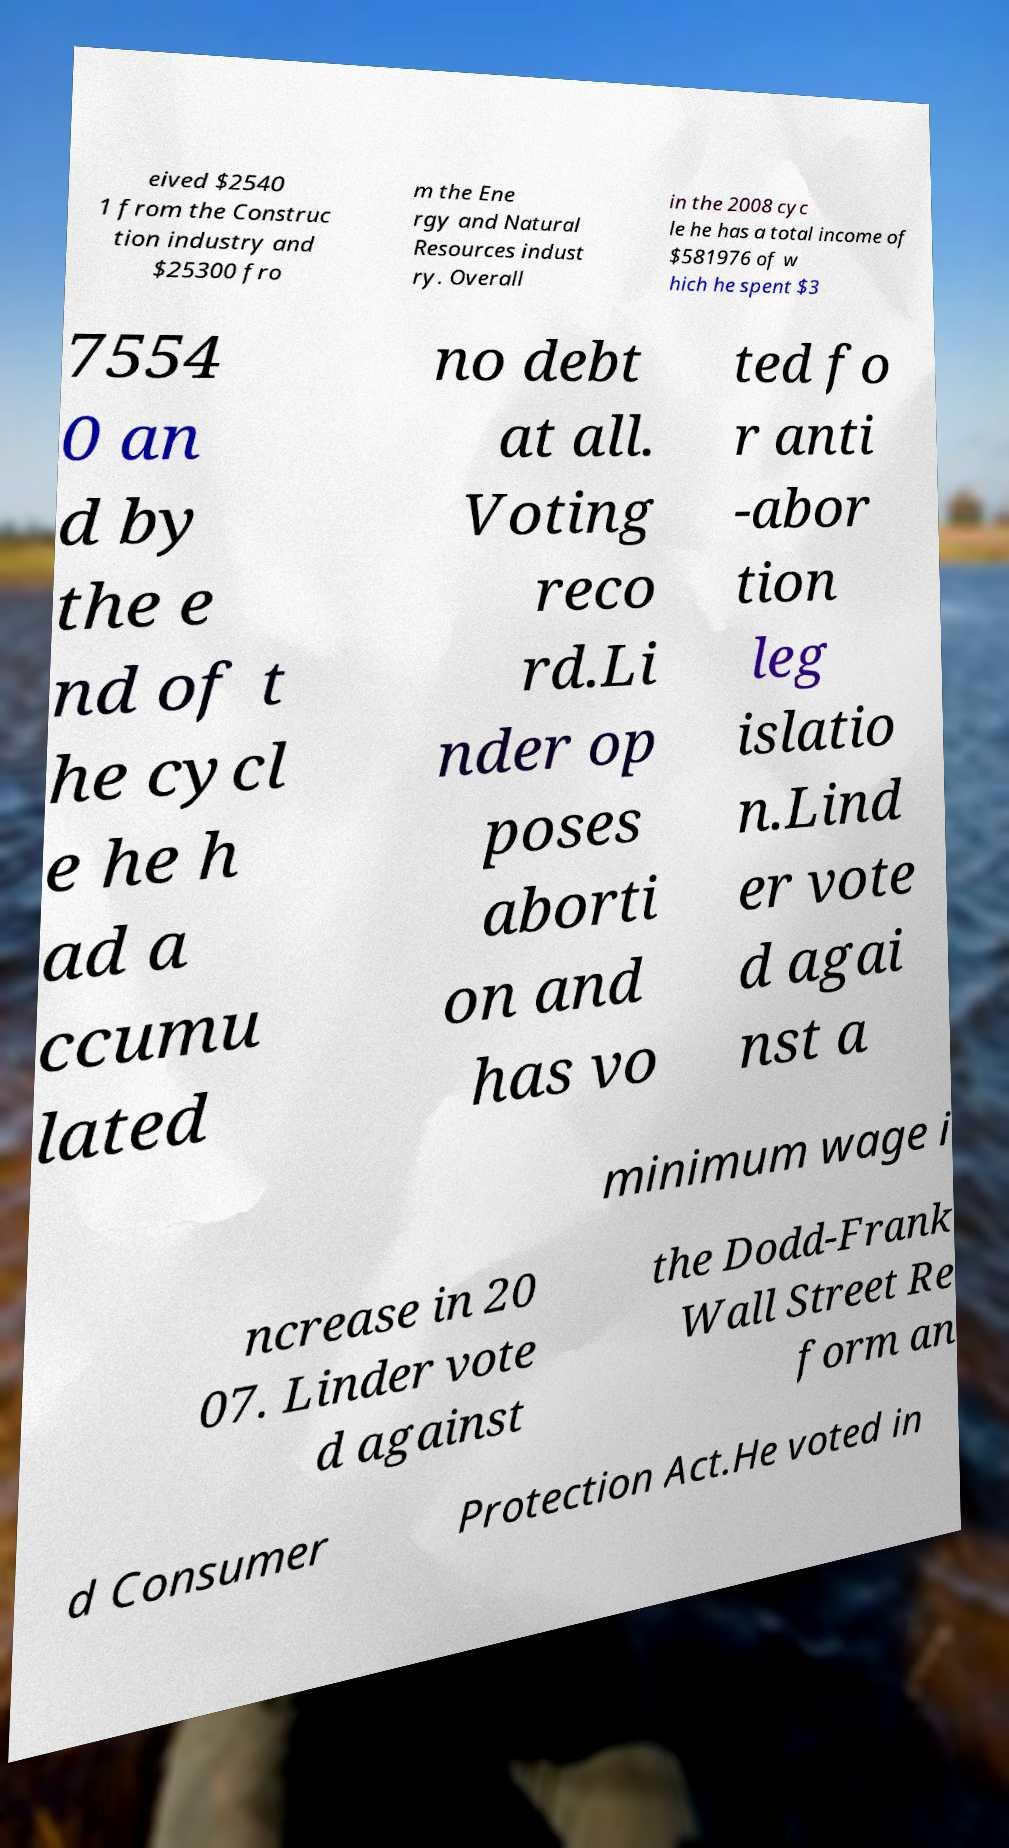I need the written content from this picture converted into text. Can you do that? eived $2540 1 from the Construc tion industry and $25300 fro m the Ene rgy and Natural Resources indust ry. Overall in the 2008 cyc le he has a total income of $581976 of w hich he spent $3 7554 0 an d by the e nd of t he cycl e he h ad a ccumu lated no debt at all. Voting reco rd.Li nder op poses aborti on and has vo ted fo r anti -abor tion leg islatio n.Lind er vote d agai nst a minimum wage i ncrease in 20 07. Linder vote d against the Dodd-Frank Wall Street Re form an d Consumer Protection Act.He voted in 